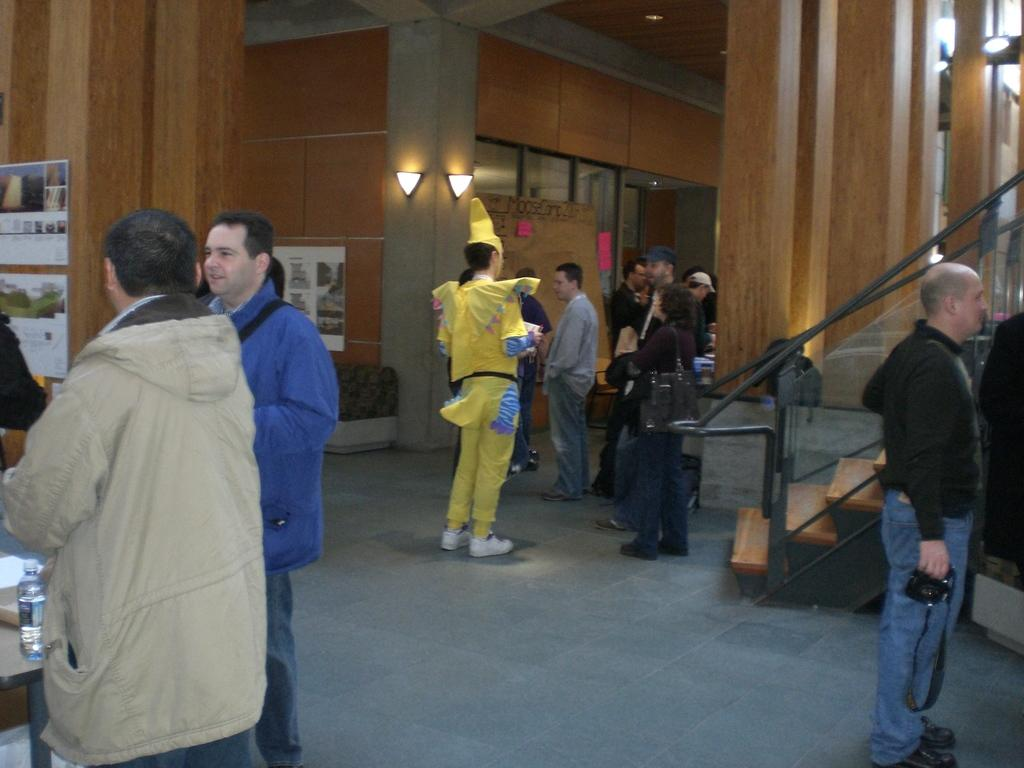How many people are visible in the image? There are many people standing in the image. Can you describe the attire of one of the individuals? One person is wearing a fancy dress in the image. What type of chain can be seen connecting the people in the image? There is no chain connecting the people in the image. 